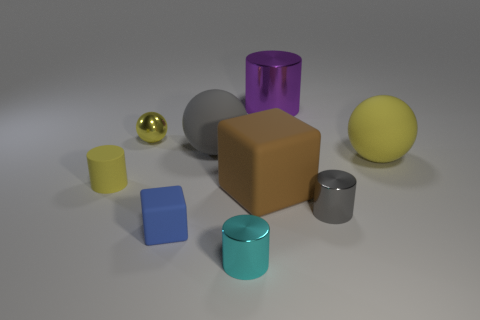Subtract all matte spheres. How many spheres are left? 1 Add 1 large cyan shiny cylinders. How many objects exist? 10 Subtract all yellow balls. How many balls are left? 1 Subtract 0 purple balls. How many objects are left? 9 Subtract all blocks. How many objects are left? 7 Subtract 2 cylinders. How many cylinders are left? 2 Subtract all blue cubes. Subtract all green balls. How many cubes are left? 1 Subtract all green cubes. How many gray cylinders are left? 1 Subtract all blocks. Subtract all big red metallic balls. How many objects are left? 7 Add 7 gray shiny objects. How many gray shiny objects are left? 8 